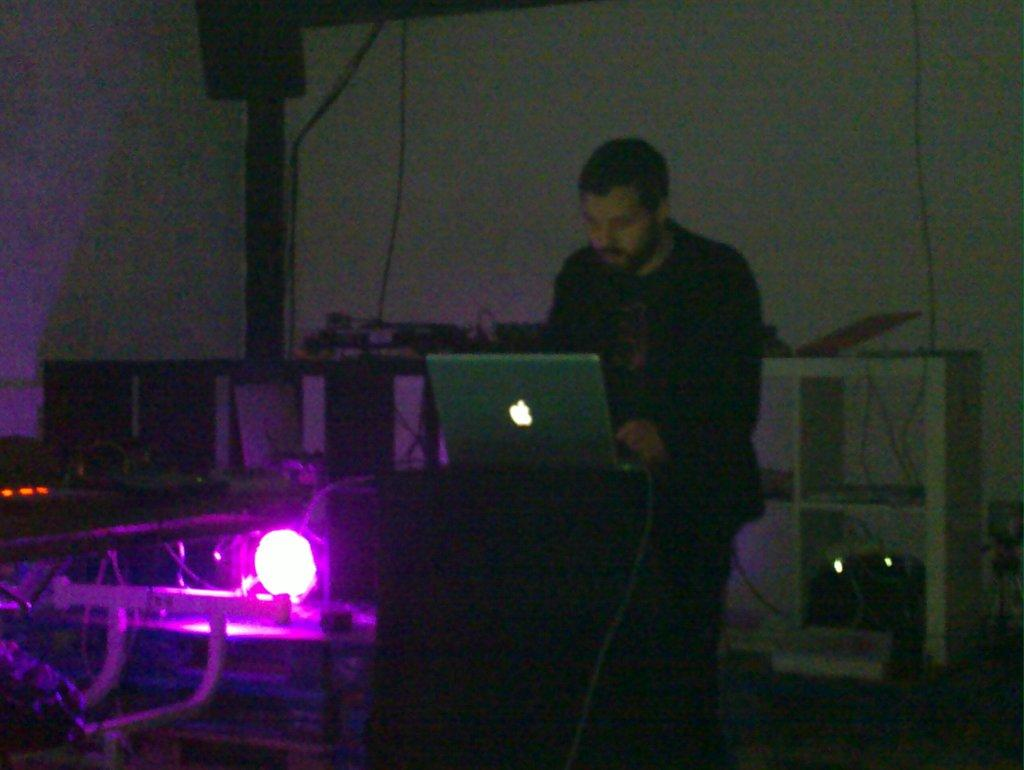Who or what is the main subject in the image? There is a person in the image. What is the person doing in the image? The person is standing in front of a laptop. Can you describe the lighting in the image? There is a light visible in the image. What can be seen in the background of the image? There is a rack and a wall in the background of the image. What type of star is visible on the person's shirt in the image? There is no star visible on the person's shirt in the image. What muscle is the person using to type on the laptop in the image? The image does not show the person typing on the laptop, so it is not possible to determine which muscle they might be using. 